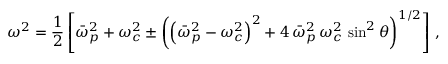<formula> <loc_0><loc_0><loc_500><loc_500>\omega ^ { 2 } = \frac { 1 } { 2 } \left [ \bar { \omega } _ { p } ^ { 2 } + \omega _ { c } ^ { 2 } \pm \left ( \left ( \bar { \omega } _ { p } ^ { 2 } - \omega _ { c } ^ { 2 } \right ) ^ { 2 } + 4 \, \bar { \omega } _ { p } ^ { 2 } \, \omega _ { c } ^ { 2 } \, \sin ^ { 2 } \theta \right ) ^ { 1 / 2 } \right ] \, ,</formula> 